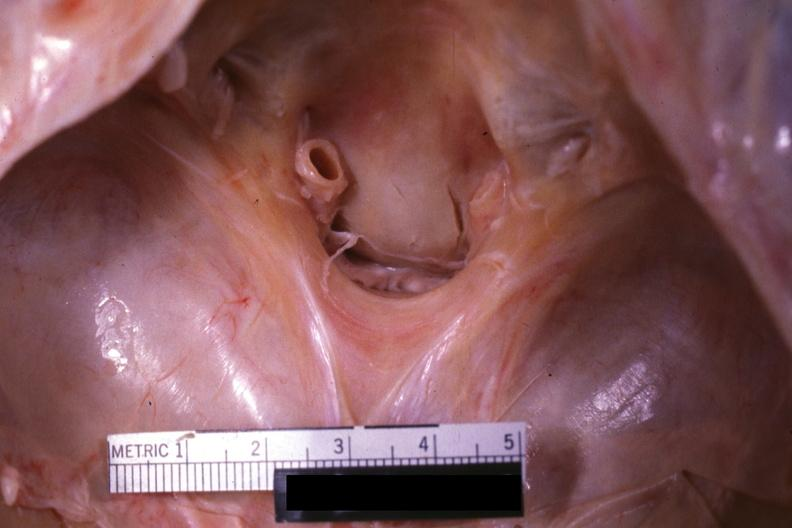what is present?
Answer the question using a single word or phrase. Odontoid process subluxation with narrowing of foramen magnum 